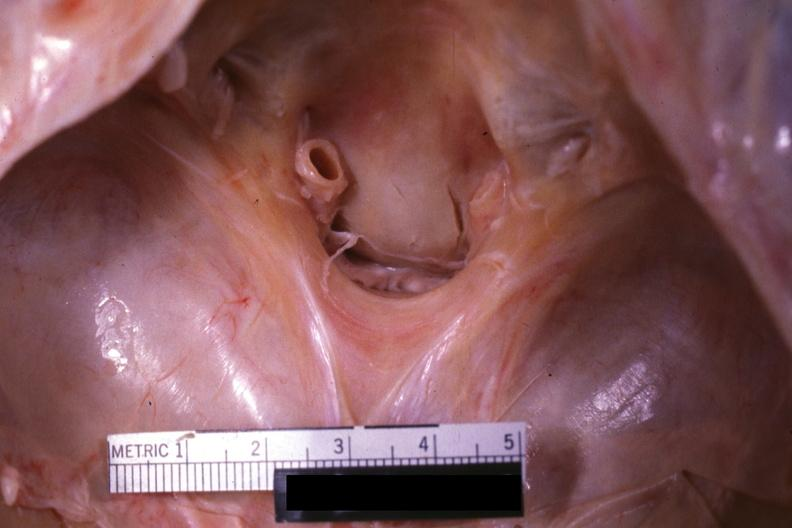what is present?
Answer the question using a single word or phrase. Odontoid process subluxation with narrowing of foramen magnum 